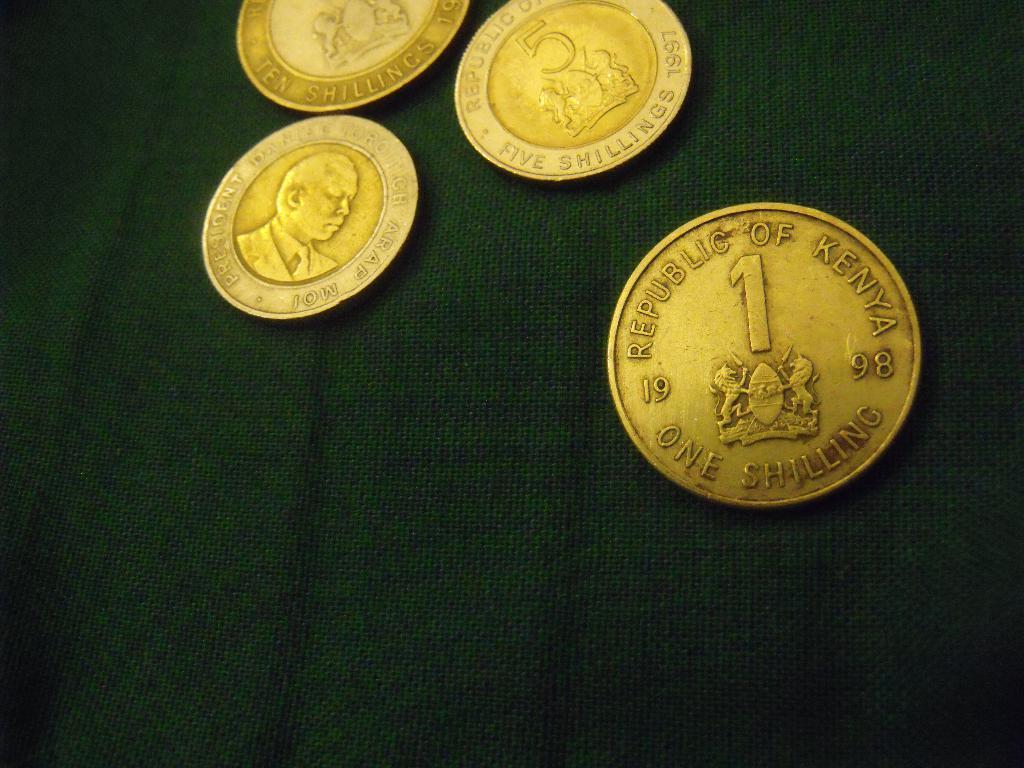What country is this coin from?
Provide a succinct answer. Kenya. How much is the coins worth?
Offer a very short reply. 1 shilling. 